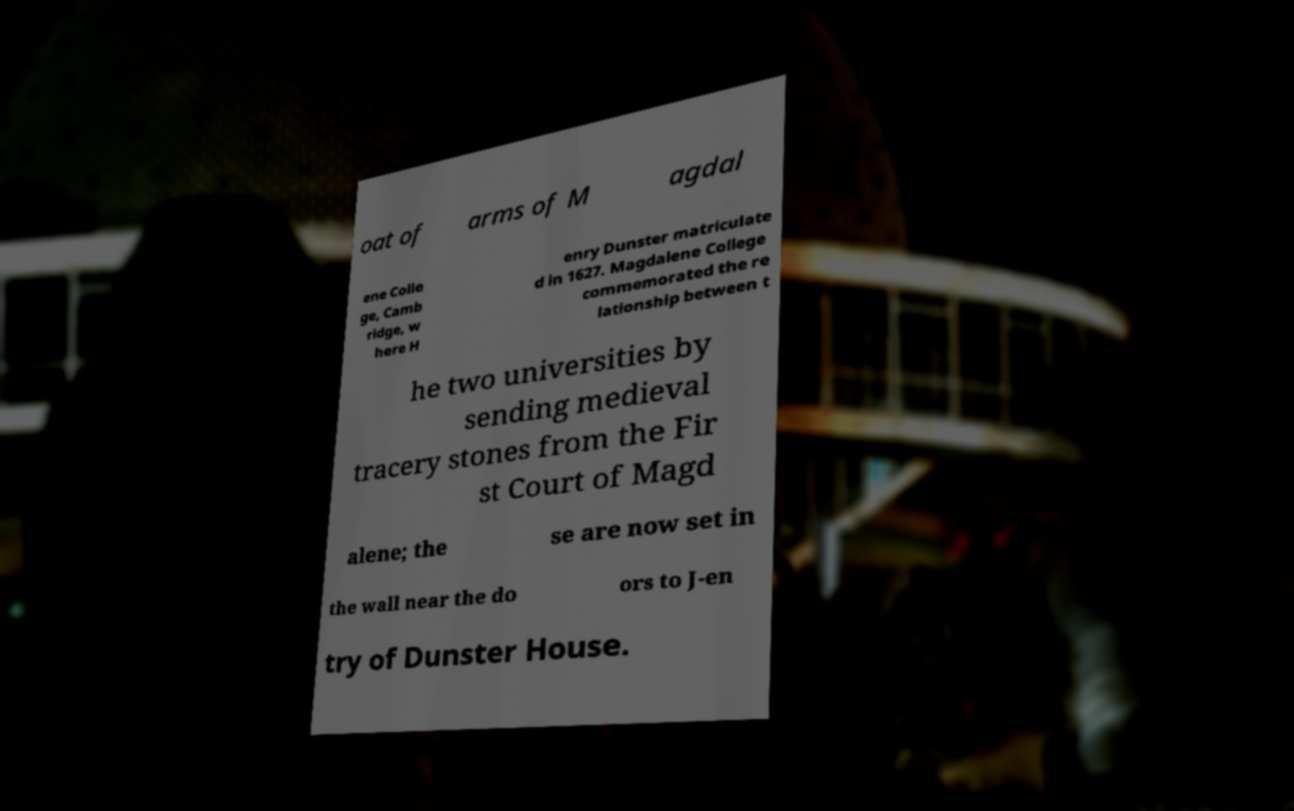Could you extract and type out the text from this image? oat of arms of M agdal ene Colle ge, Camb ridge, w here H enry Dunster matriculate d in 1627. Magdalene College commemorated the re lationship between t he two universities by sending medieval tracery stones from the Fir st Court of Magd alene; the se are now set in the wall near the do ors to J-en try of Dunster House. 